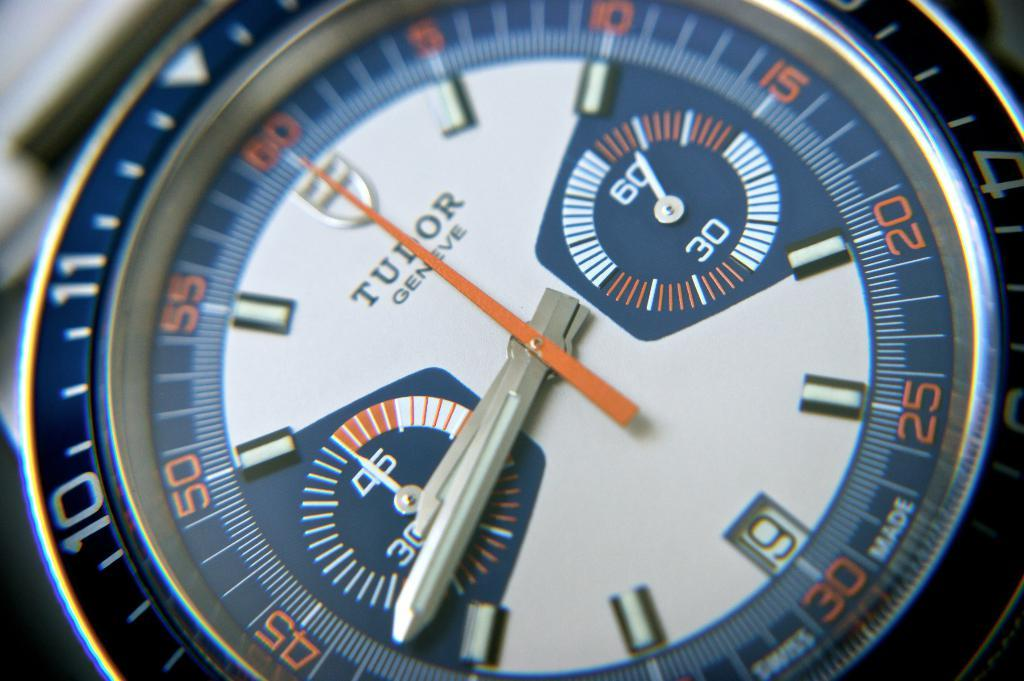<image>
Share a concise interpretation of the image provided. A Tudor brand watch is shown with a white face. 